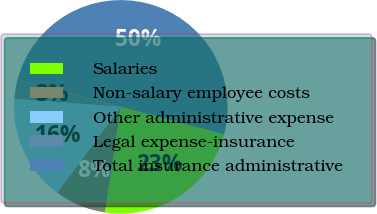Convert chart. <chart><loc_0><loc_0><loc_500><loc_500><pie_chart><fcel>Salaries<fcel>Non-salary employee costs<fcel>Other administrative expense<fcel>Legal expense-insurance<fcel>Total insurance administrative<nl><fcel>23.23%<fcel>7.81%<fcel>16.04%<fcel>2.92%<fcel>50.0%<nl></chart> 